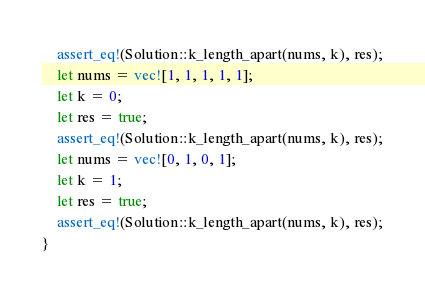Convert code to text. <code><loc_0><loc_0><loc_500><loc_500><_Rust_>    assert_eq!(Solution::k_length_apart(nums, k), res);
    let nums = vec![1, 1, 1, 1, 1];
    let k = 0;
    let res = true;
    assert_eq!(Solution::k_length_apart(nums, k), res);
    let nums = vec![0, 1, 0, 1];
    let k = 1;
    let res = true;
    assert_eq!(Solution::k_length_apart(nums, k), res);
}
</code> 